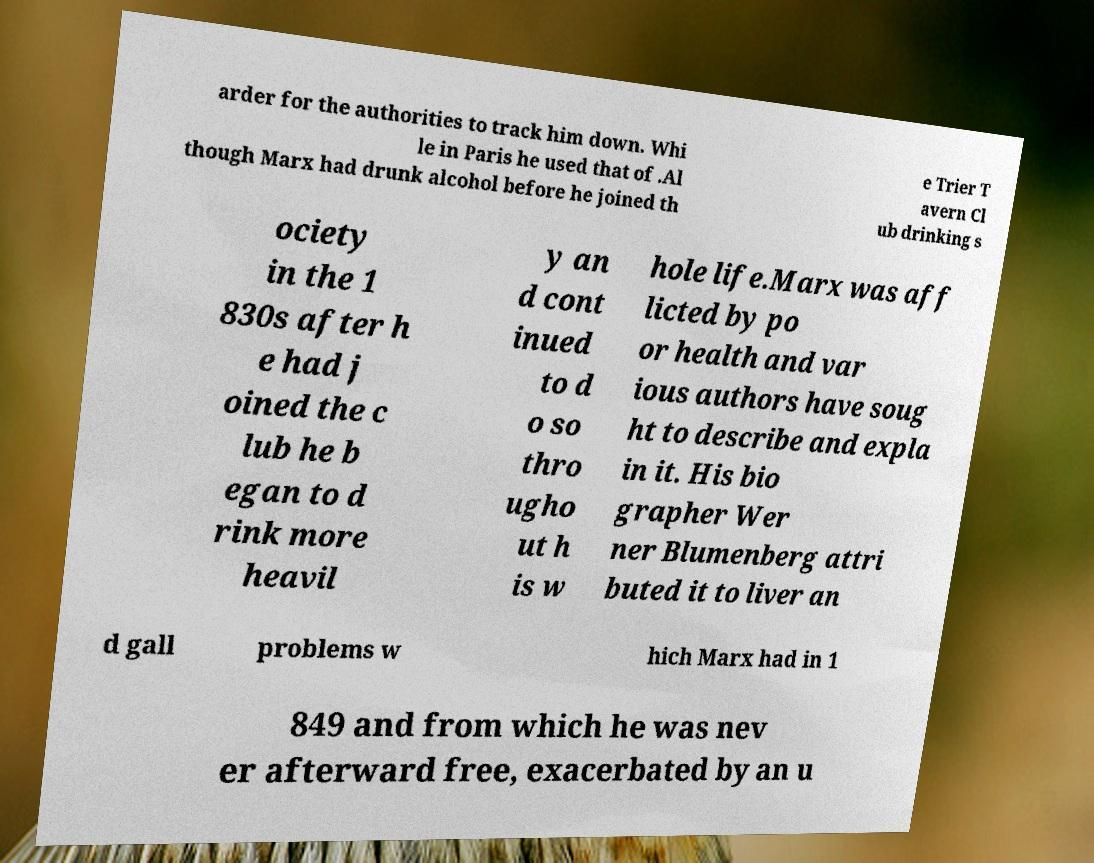There's text embedded in this image that I need extracted. Can you transcribe it verbatim? arder for the authorities to track him down. Whi le in Paris he used that of .Al though Marx had drunk alcohol before he joined th e Trier T avern Cl ub drinking s ociety in the 1 830s after h e had j oined the c lub he b egan to d rink more heavil y an d cont inued to d o so thro ugho ut h is w hole life.Marx was aff licted by po or health and var ious authors have soug ht to describe and expla in it. His bio grapher Wer ner Blumenberg attri buted it to liver an d gall problems w hich Marx had in 1 849 and from which he was nev er afterward free, exacerbated by an u 